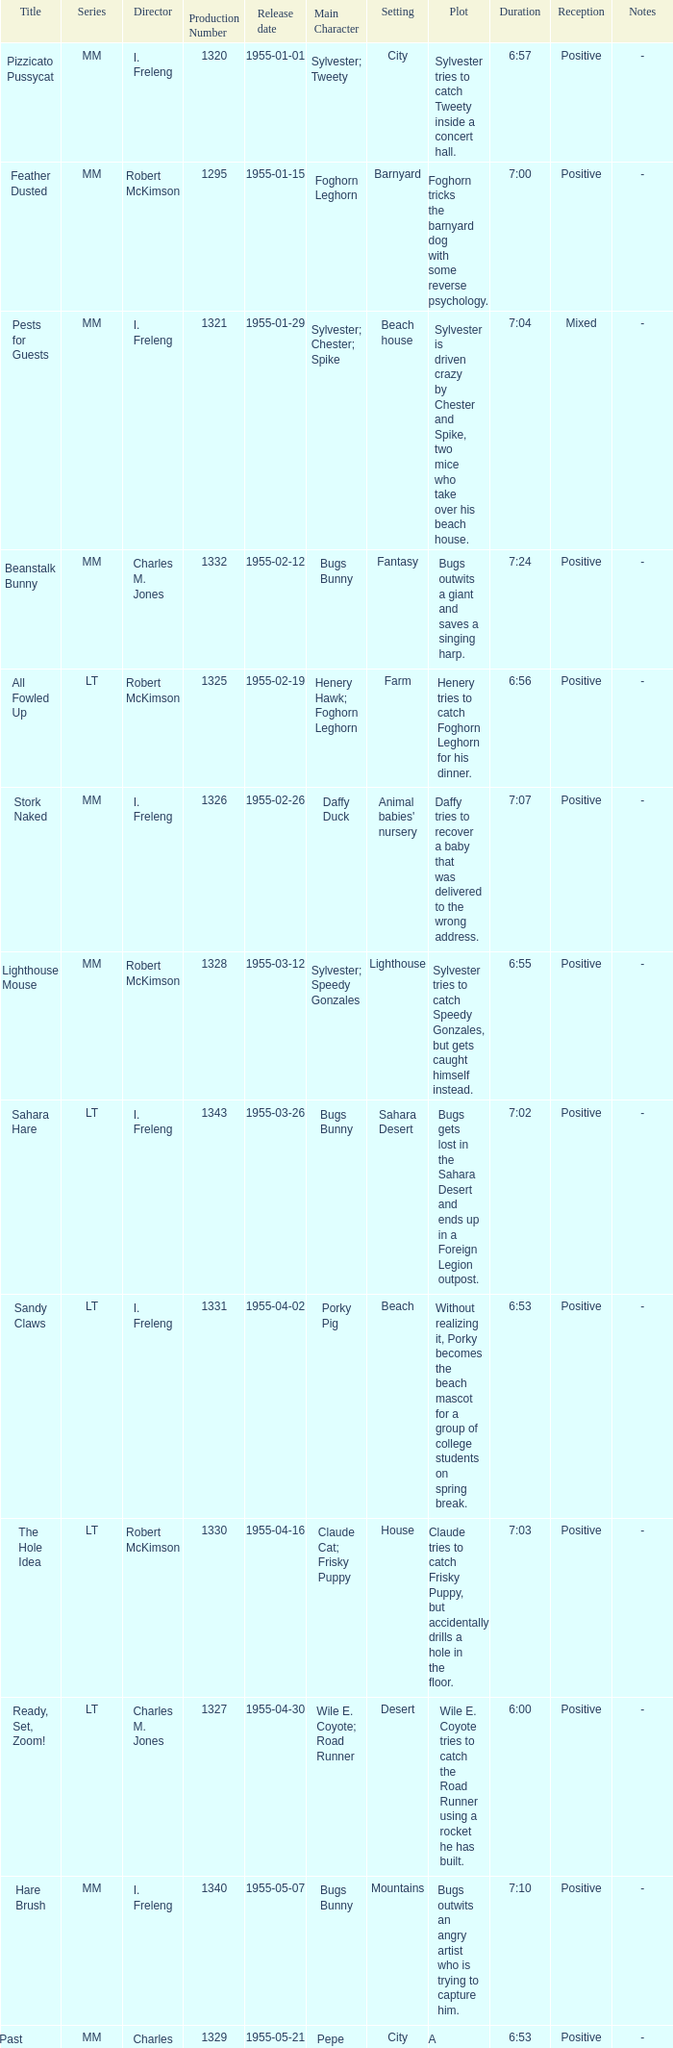What is the title with the production number greater than 1334 released on 1955-08-27? Hyde and Hare. 